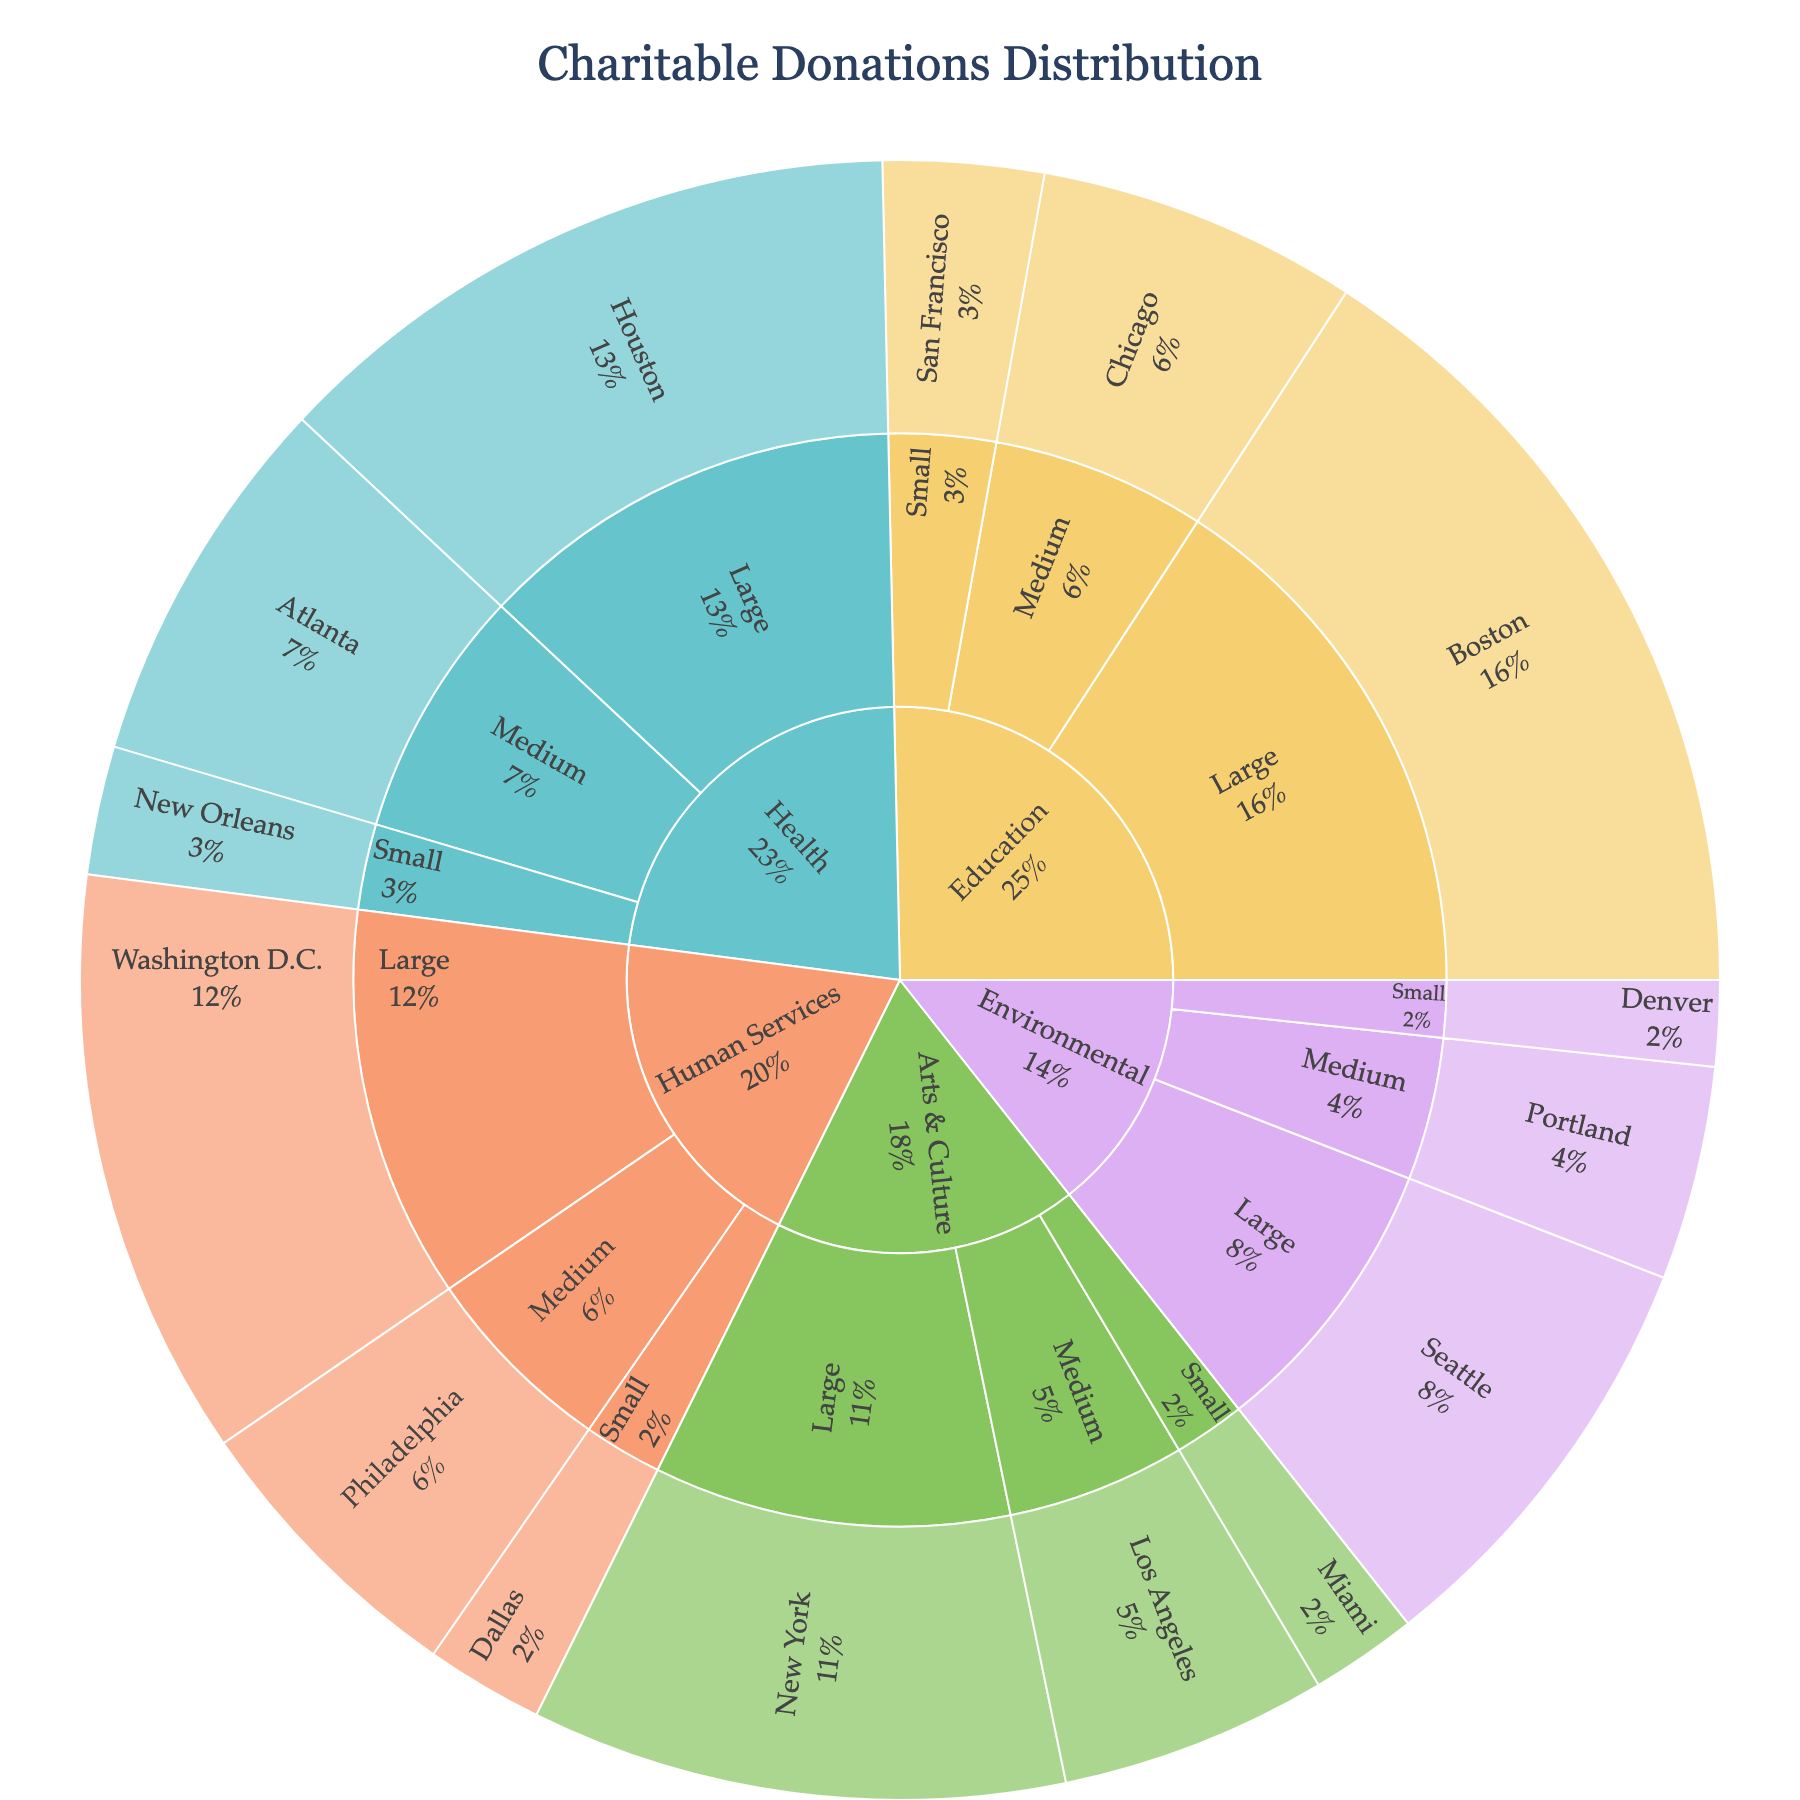Which cause received the largest total amount of donations? The sunburst plot will show the largest segment for the cause that received the highest total donations. You can determine this by identifying the largest outer ring segment.
Answer: Education What percentage of donations went to Human Services organizations? Find the Human Services segment in the plot and read the percentage displayed. It represents the portion of total donations allocated to Human Services.
Answer: 18.33% Between Large and Medium-sized Arts & Culture organizations, which received more donations? Compare the sizes of the segments for Large and Medium Arts & Culture organizations. The larger segment has received more donations.
Answer: Large How do Environmental donations compare between Small and Large organizations? Locate the segments for Small and Large organizations under the Environmental cause and compare their sizes or values displayed on hover.
Answer: Large organizations received more Which geographic region received the least amount of donations for Health causes? Navigate to the segments associated with Health causes and compare the regions under Small organizations. The smallest segment represents the least amount of donations.
Answer: New Orleans What is the total amount of donations received by Medium-sized organizations across all causes? Sum the donations for all Medium-sized organization segments for each cause.
Answer: $1,375,000 How do the donations for Large organizations in Environmental compare to those in Health? Find the segments for Large organizations under Environmental and Health, compare their sizes or values.
Answer: Health received more What proportion of donations did New York receive within the Arts & Culture cause? Locate the New York segment under Large Arts & Culture and read its percentage value.
Answer: 33.33% Which cause has the smallest percentage of donations and what is the value? Identify the smallest outer ring segment and find its percentage and monetary value.
Answer: Environmental, $680,000 How do donations to Small organizations in Human Services compare with those in Arts & Culture? Find and compare the segments for Small organizations under Human Services and Arts & Culture by their sizes or values.
Answer: Human Services received more 